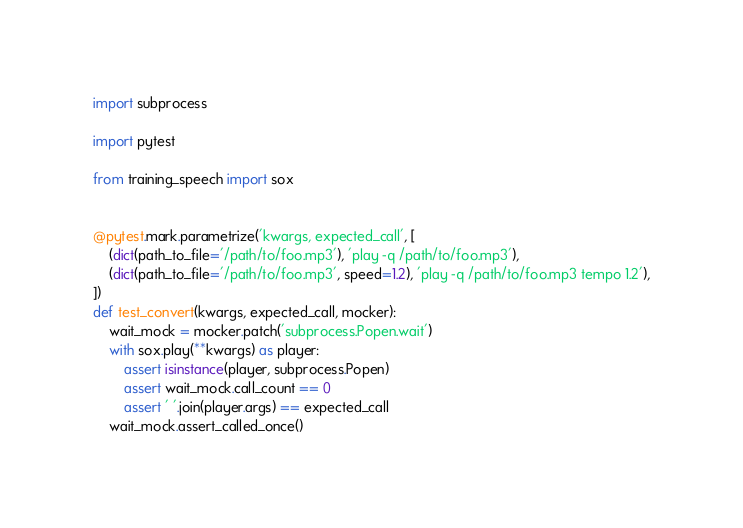Convert code to text. <code><loc_0><loc_0><loc_500><loc_500><_Python_>import subprocess

import pytest

from training_speech import sox


@pytest.mark.parametrize('kwargs, expected_call', [
    (dict(path_to_file='/path/to/foo.mp3'), 'play -q /path/to/foo.mp3'),
    (dict(path_to_file='/path/to/foo.mp3', speed=1.2), 'play -q /path/to/foo.mp3 tempo 1.2'),
])
def test_convert(kwargs, expected_call, mocker):
    wait_mock = mocker.patch('subprocess.Popen.wait')
    with sox.play(**kwargs) as player:
        assert isinstance(player, subprocess.Popen)
        assert wait_mock.call_count == 0
        assert ' '.join(player.args) == expected_call
    wait_mock.assert_called_once()
</code> 